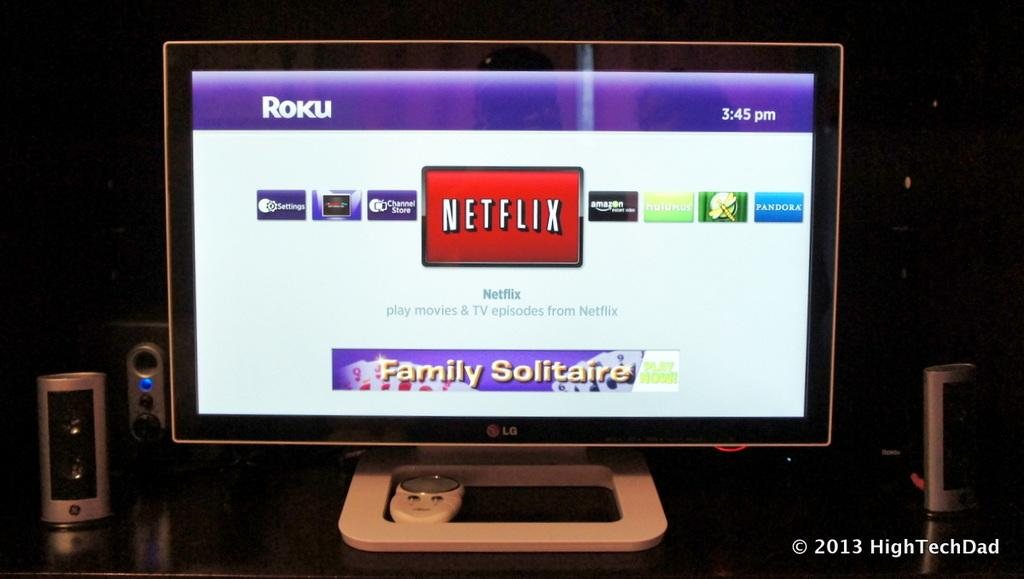Provide a one-sentence caption for the provided image. A computer monitor shows the Roku screen wit the Netflix icon in the center of the screen and Family Solitaire at the bottom. 